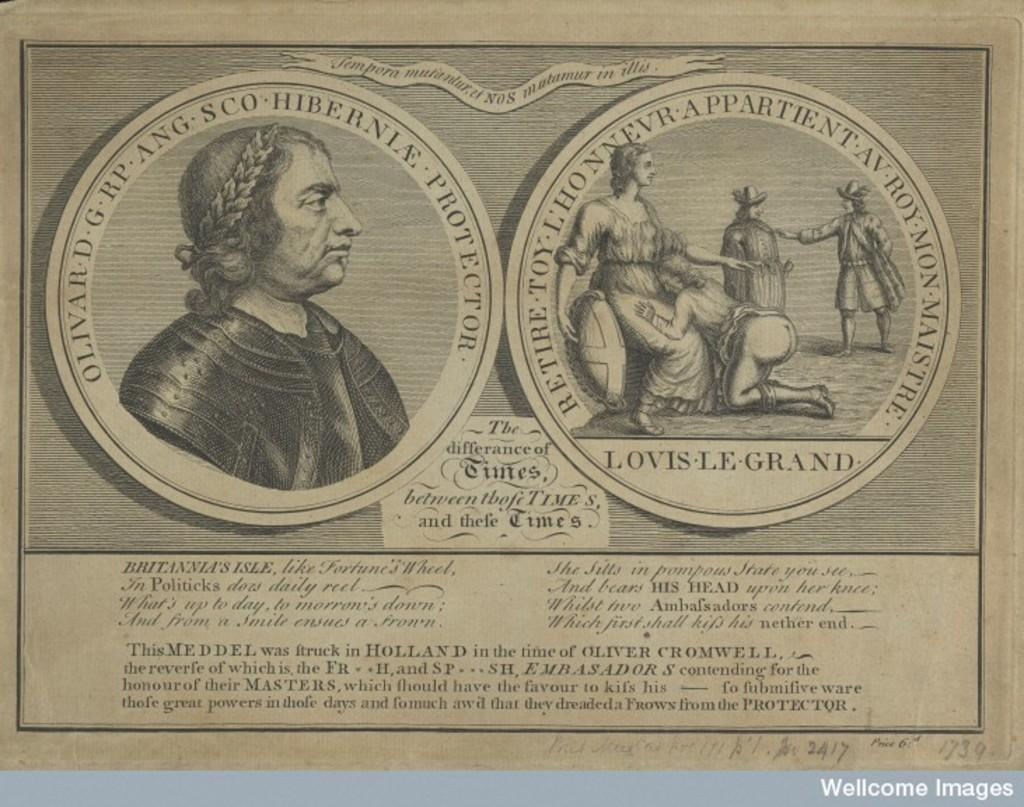How many images are present in the picture? There are two different images in the picture. What can be found below the images? There is information mentioned below the images. What type of wren can be seen in the image? There is no wren present in the image; it only contains two different images. Where did the people in the image go on vacation? There is no information about people going on vacation in the image; it only contains two different images and information below them. 